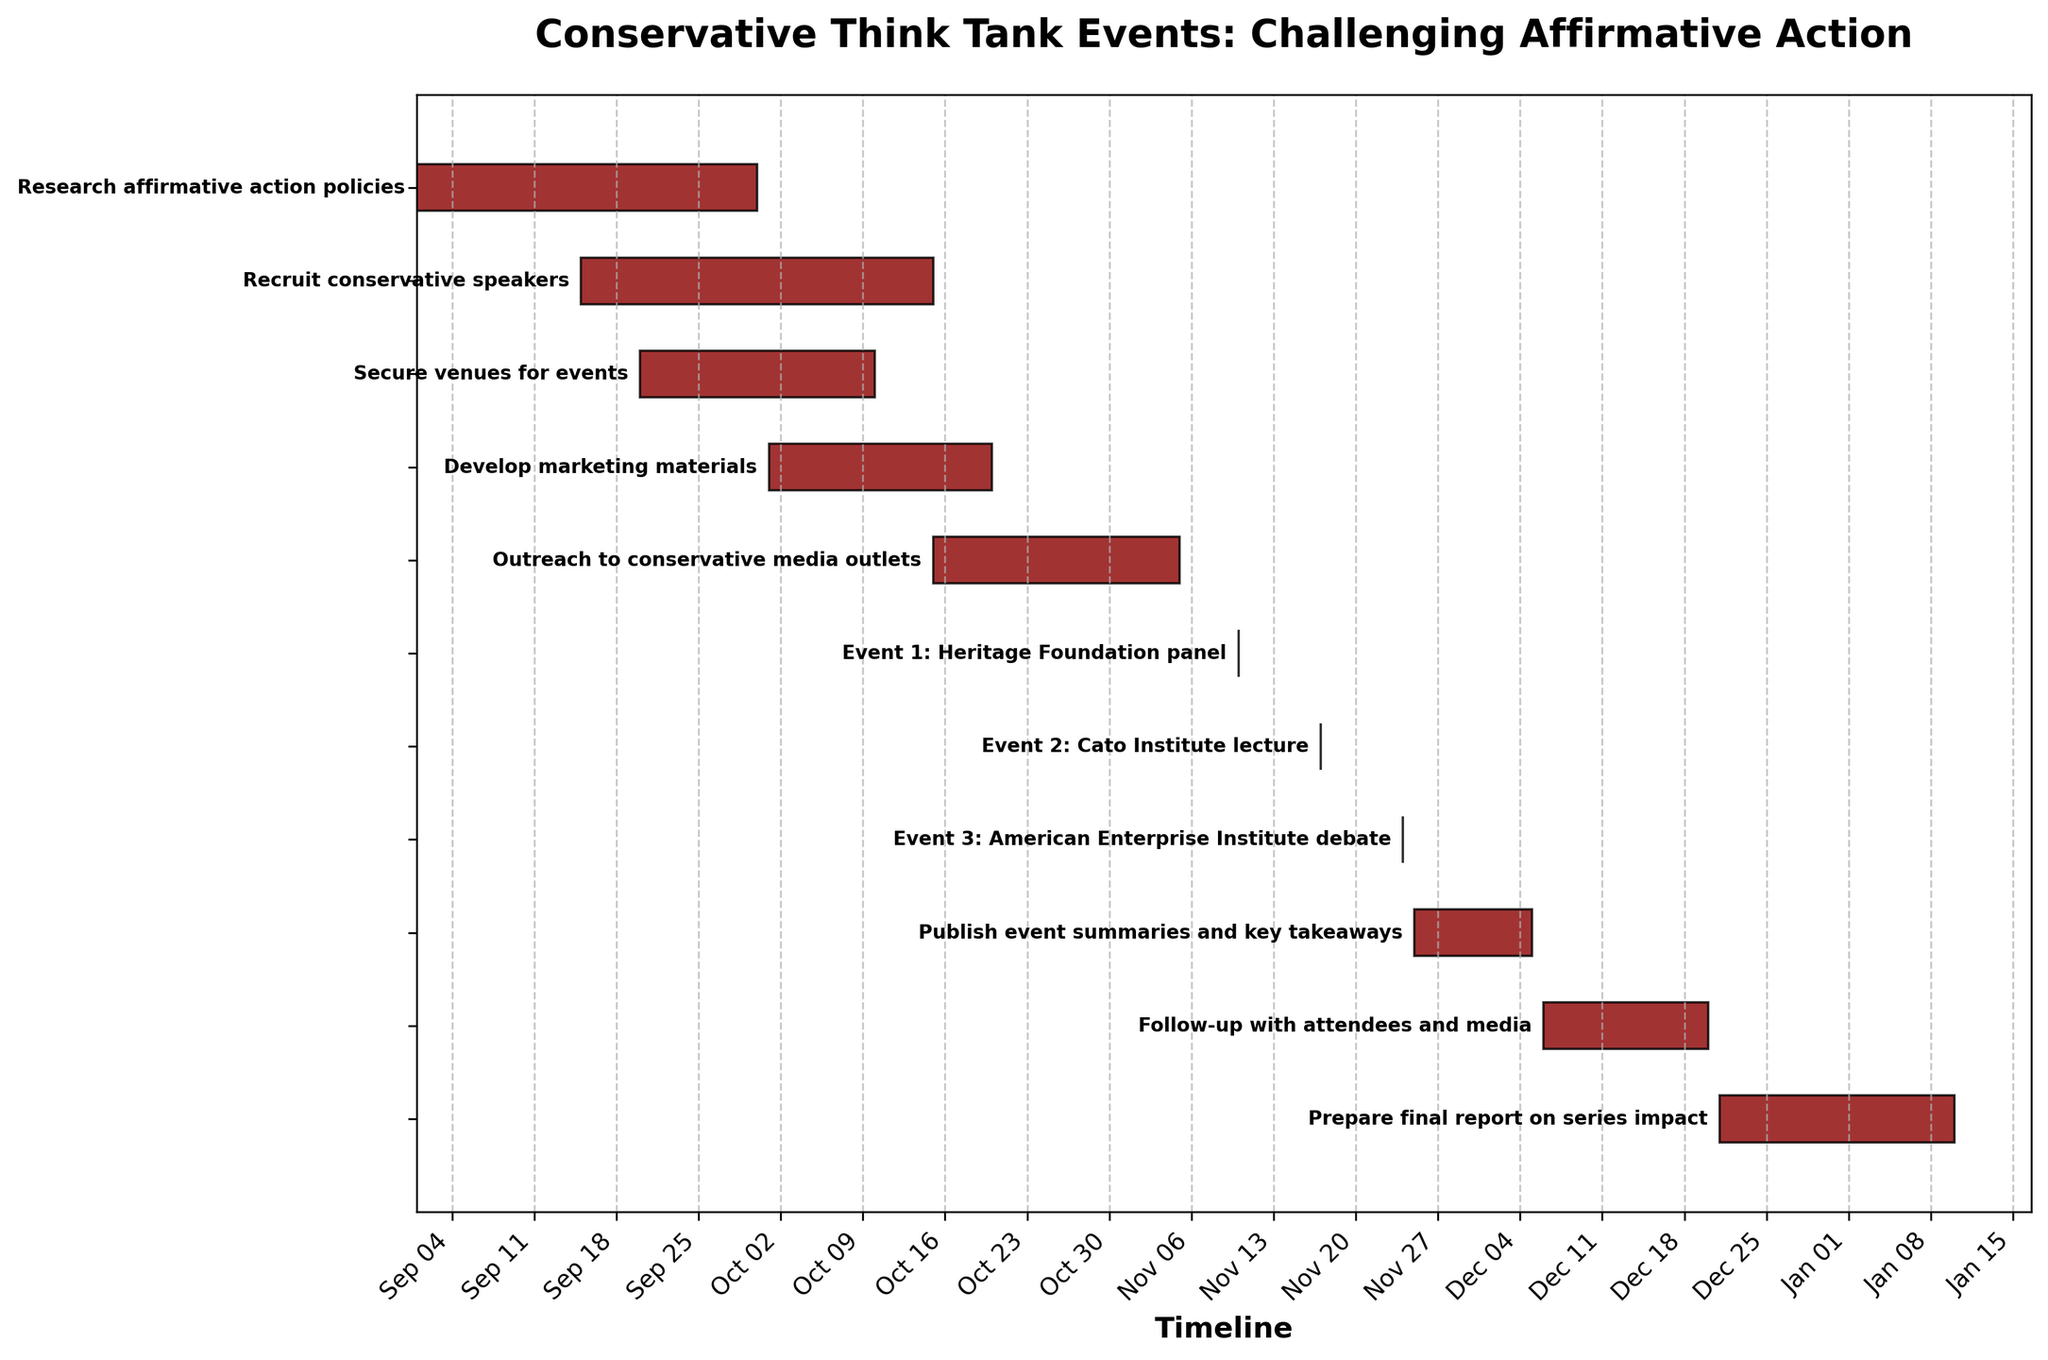What is the title of the Gantt Chart? The title of the Gantt Chart is prominently displayed at the top of the figure in bold text. It reads: "Conservative Think Tank Events: Challenging Affirmative Action"
Answer: Conservative Think Tank Events: Challenging Affirmative Action Which task starts the earliest, and when does it begin? The earliest starting task is "Research affirmative action policies," which begins on 2023-09-01 as indicated by the start date on the Gantt Chart.
Answer: Research affirmative action policies, 2023-09-01 How long does the task "Develop marketing materials" take to complete? The task "Develop marketing materials" starts on 2023-10-01 and ends on 2023-10-20. To find the duration, subtract the start date from the end date. (2023-10-20 minus 2023-10-01)
Answer: 19 days Which event occurs first and on what date? The Gantt Chart lists the events and their specific dates. The first event listed is "Event 1: Heritage Foundation panel," which occurs on 2023-11-10.
Answer: Event 1: Heritage Foundation panel, 2023-11-10 What tasks overlap with "Recruit conservative speakers"? "Recruit conservative speakers" spans from 2023-09-15 to 2023-10-15. Tasks overlapping this period include "Research affirmative action policies," "Secure venues for events," and "Develop marketing materials."
Answer: Research affirmative action policies, Secure venues for events, Develop marketing materials How many days are spent on outreach to conservative media outlets? The task "Outreach to conservative media outlets" starts on 2023-10-15 and ends on 2023-11-05. To calculate the duration, subtract the start date from the end date (2023-11-05 minus 2023-10-15).
Answer: 21 days What is the final task in the series and its time frame? The last task listed on the Gantt Chart is "Prepare final report on series impact," which spans from 2023-12-21 to 2024-01-10.
Answer: Prepare final report on series impact, 2023-12-21 to 2024-01-10 Between "Event 2: Cato Institute lecture" and "Event 3: American Enterprise Institute debate," which one occurs first? The Gantt Chart shows "Event 2: Cato Institute lecture" on 2023-11-17, followed by "Event 3: American Enterprise Institute debate" on 2023-11-24.
Answer: Event 2: Cato Institute lecture What is the duration between the end of "Publish event summaries and key takeaways" and the start of "Prepare final report on series impact"? "Publish event summaries and key takeaways" ends on 2023-12-05, while "Prepare final report on series impact" starts on 2023-12-21. Subtract the end date of the first task from the start date of the second task (2023-12-21 minus 2023-12-05).
Answer: 16 days 